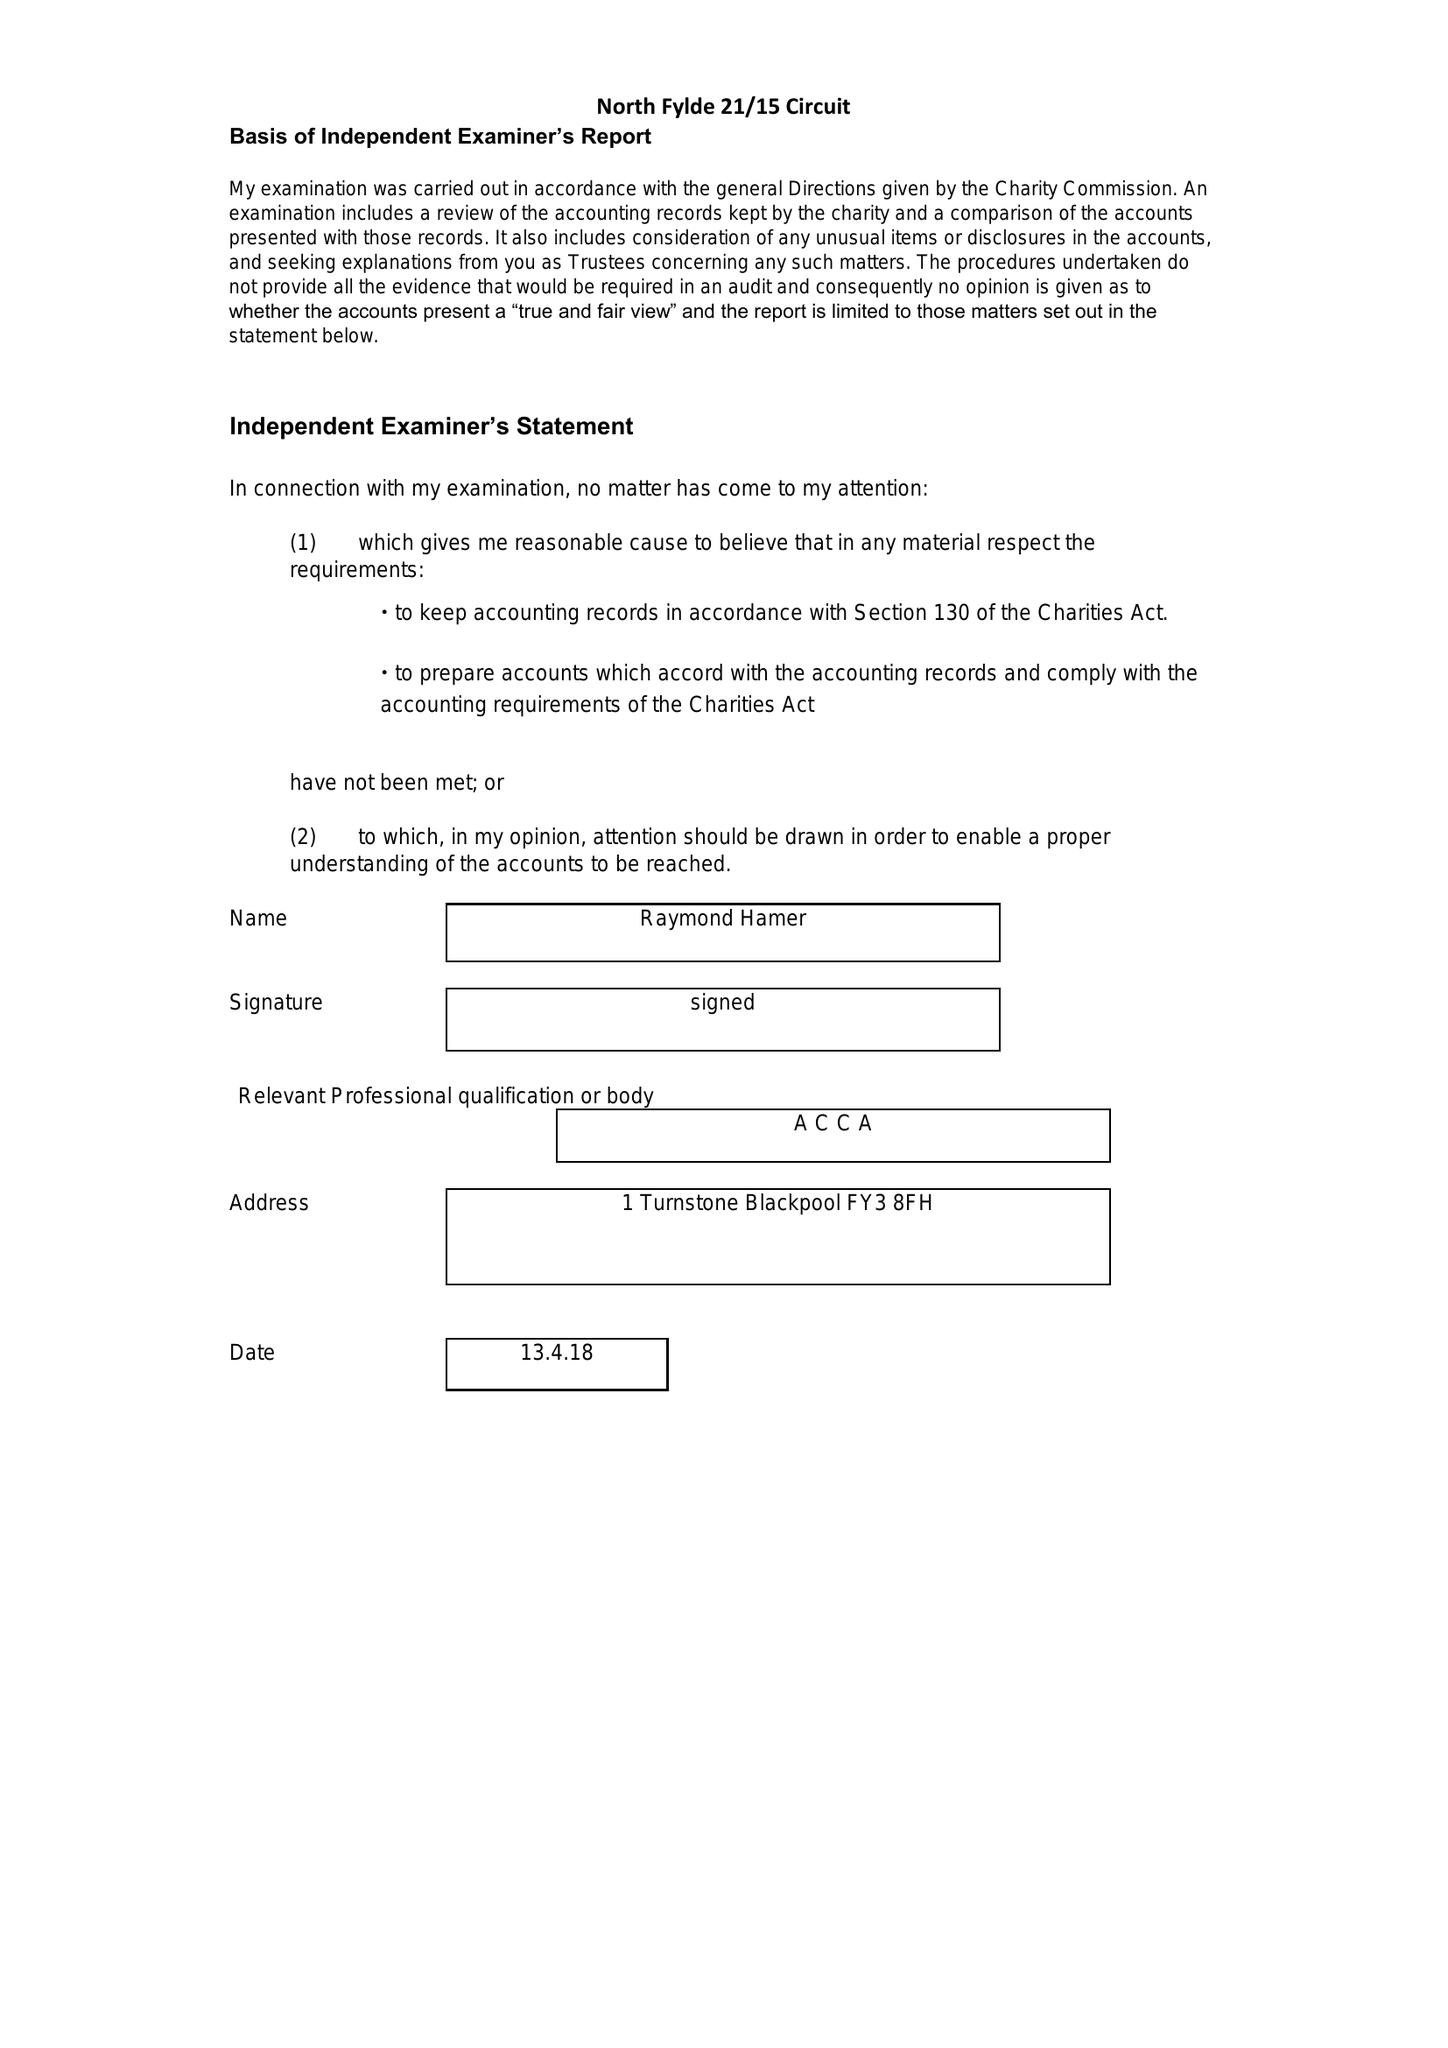What is the value for the spending_annually_in_british_pounds?
Answer the question using a single word or phrase. 318223.00 